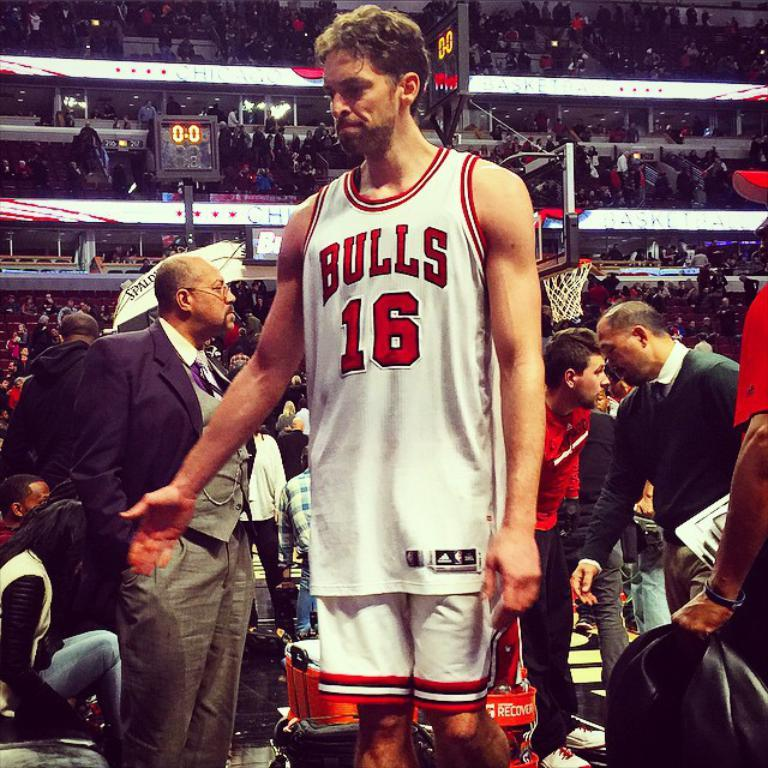Provide a one-sentence caption for the provided image. A player for the Bulls stands in a crowd of people. 